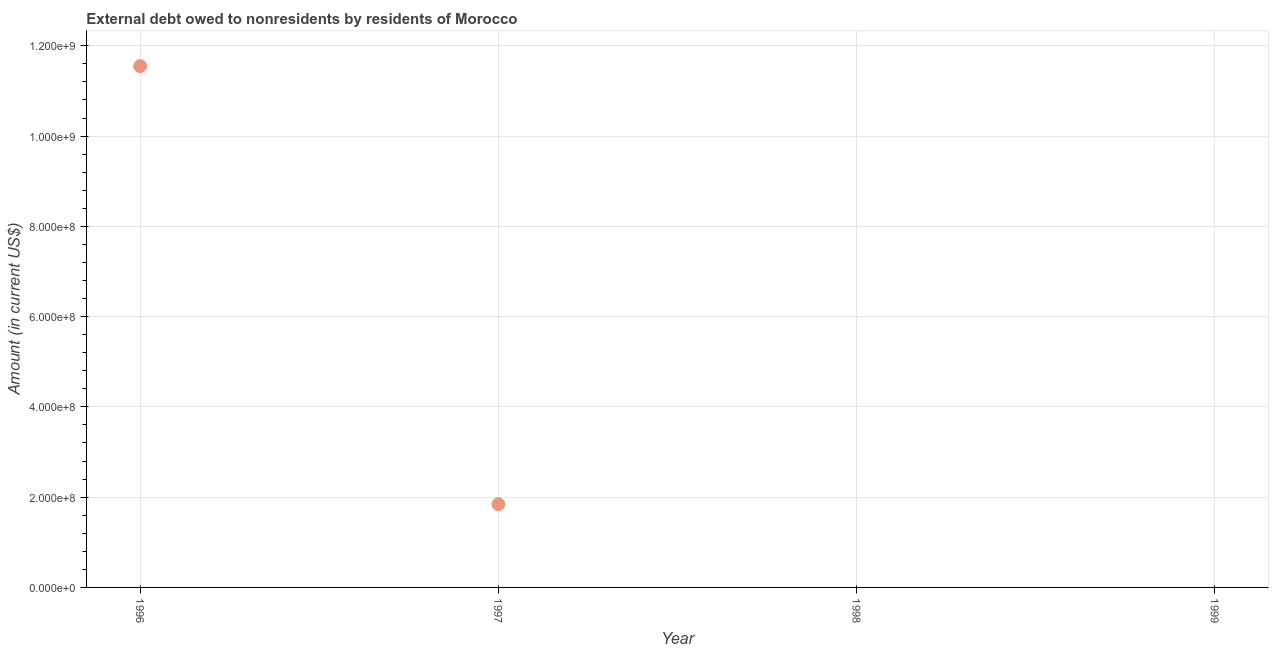Across all years, what is the maximum debt?
Give a very brief answer. 1.16e+09. Across all years, what is the minimum debt?
Give a very brief answer. 0. What is the sum of the debt?
Your answer should be compact. 1.34e+09. What is the difference between the debt in 1996 and 1997?
Your answer should be compact. 9.71e+08. What is the average debt per year?
Offer a terse response. 3.35e+08. What is the median debt?
Offer a terse response. 9.22e+07. In how many years, is the debt greater than 80000000 US$?
Your answer should be very brief. 2. What is the ratio of the debt in 1996 to that in 1997?
Your answer should be very brief. 6.27. What is the difference between the highest and the lowest debt?
Your answer should be compact. 1.16e+09. Does the debt monotonically increase over the years?
Your answer should be compact. No. What is the title of the graph?
Offer a terse response. External debt owed to nonresidents by residents of Morocco. What is the label or title of the X-axis?
Your response must be concise. Year. What is the Amount (in current US$) in 1996?
Provide a short and direct response. 1.16e+09. What is the Amount (in current US$) in 1997?
Your answer should be very brief. 1.84e+08. What is the Amount (in current US$) in 1999?
Your response must be concise. 0. What is the difference between the Amount (in current US$) in 1996 and 1997?
Keep it short and to the point. 9.71e+08. What is the ratio of the Amount (in current US$) in 1996 to that in 1997?
Your response must be concise. 6.26. 